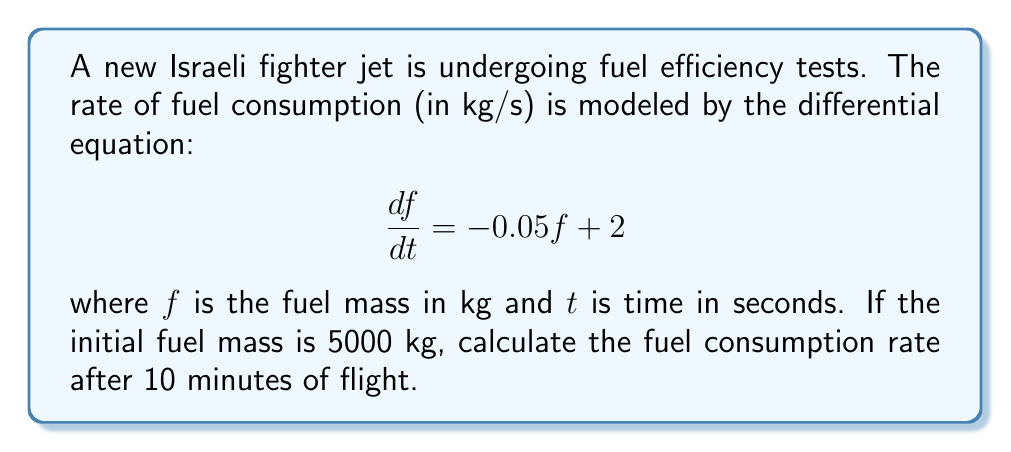Could you help me with this problem? To solve this problem, we need to follow these steps:

1) First, we recognize this as a first-order linear differential equation in the form:

   $$\frac{df}{dt} + Pf = Q$$

   where $P = 0.05$ and $Q = 2$

2) The general solution for this type of equation is:

   $$f(t) = e^{-\int P dt} (\int Q e^{\int P dt} dt + C)$$

3) Solving the integrals:

   $\int P dt = 0.05t$
   $e^{\int P dt} = e^{0.05t}$

4) Substituting into the general solution:

   $$f(t) = e^{-0.05t} (\int 2e^{0.05t} dt + C)$$

5) Solving the remaining integral:

   $$f(t) = e^{-0.05t} (\frac{2}{0.05}e^{0.05t} + C)$$
   $$f(t) = 40 + Ce^{-0.05t}$$

6) Using the initial condition $f(0) = 5000$:

   $5000 = 40 + C$
   $C = 4960$

7) Therefore, the particular solution is:

   $$f(t) = 40 + 4960e^{-0.05t}$$

8) To find the fuel consumption rate at $t = 600$ seconds (10 minutes), we need to calculate $\frac{df}{dt}$ at $t = 600$:

   $$\frac{df}{dt} = -0.05(40 + 4960e^{-0.05t}) + 2$$

9) Substituting $t = 600$:

   $$\frac{df}{dt} = -0.05(40 + 4960e^{-0.05(600)}) + 2$$
   $$= -0.05(40 + 4960e^{-30}) + 2$$
   $$\approx -0.05(40.00) + 2$$
   $$\approx -2.00 + 2$$
   $$\approx 0$$
Answer: The fuel consumption rate after 10 minutes of flight is approximately 0 kg/s. 